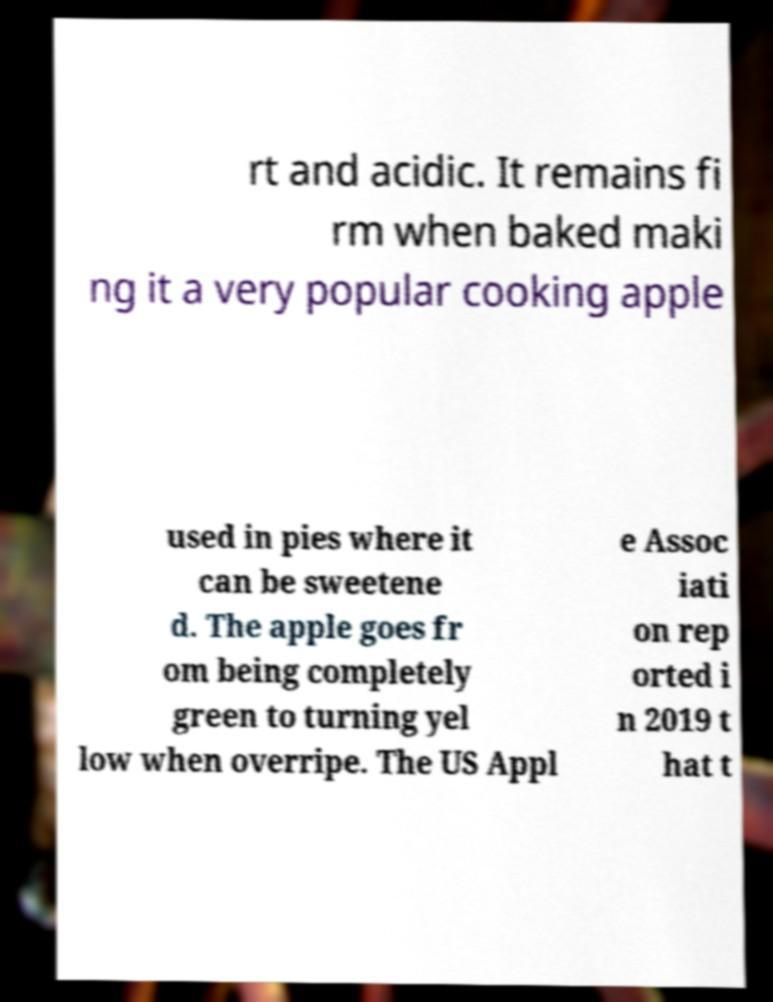There's text embedded in this image that I need extracted. Can you transcribe it verbatim? rt and acidic. It remains fi rm when baked maki ng it a very popular cooking apple used in pies where it can be sweetene d. The apple goes fr om being completely green to turning yel low when overripe. The US Appl e Assoc iati on rep orted i n 2019 t hat t 